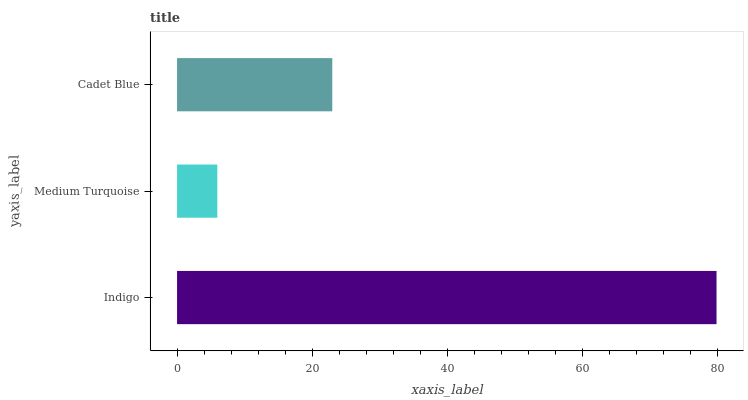Is Medium Turquoise the minimum?
Answer yes or no. Yes. Is Indigo the maximum?
Answer yes or no. Yes. Is Cadet Blue the minimum?
Answer yes or no. No. Is Cadet Blue the maximum?
Answer yes or no. No. Is Cadet Blue greater than Medium Turquoise?
Answer yes or no. Yes. Is Medium Turquoise less than Cadet Blue?
Answer yes or no. Yes. Is Medium Turquoise greater than Cadet Blue?
Answer yes or no. No. Is Cadet Blue less than Medium Turquoise?
Answer yes or no. No. Is Cadet Blue the high median?
Answer yes or no. Yes. Is Cadet Blue the low median?
Answer yes or no. Yes. Is Medium Turquoise the high median?
Answer yes or no. No. Is Medium Turquoise the low median?
Answer yes or no. No. 